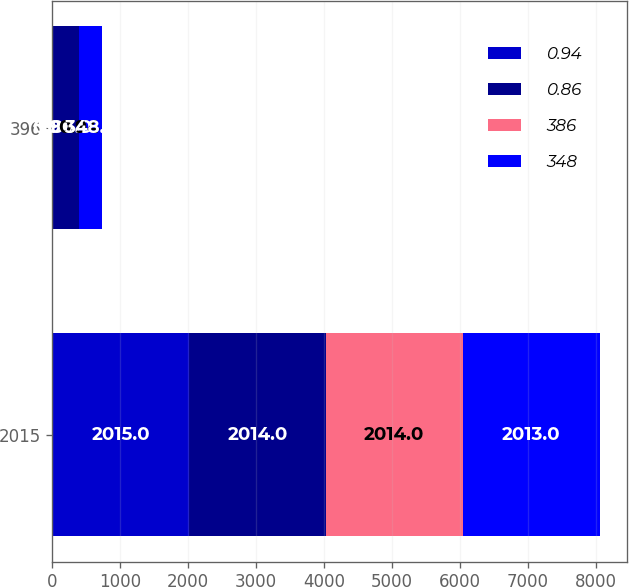<chart> <loc_0><loc_0><loc_500><loc_500><stacked_bar_chart><ecel><fcel>2015<fcel>396<nl><fcel>0.94<fcel>2015<fcel>0.96<nl><fcel>0.86<fcel>2014<fcel>386<nl><fcel>386<fcel>2014<fcel>0.94<nl><fcel>348<fcel>2013<fcel>348<nl></chart> 